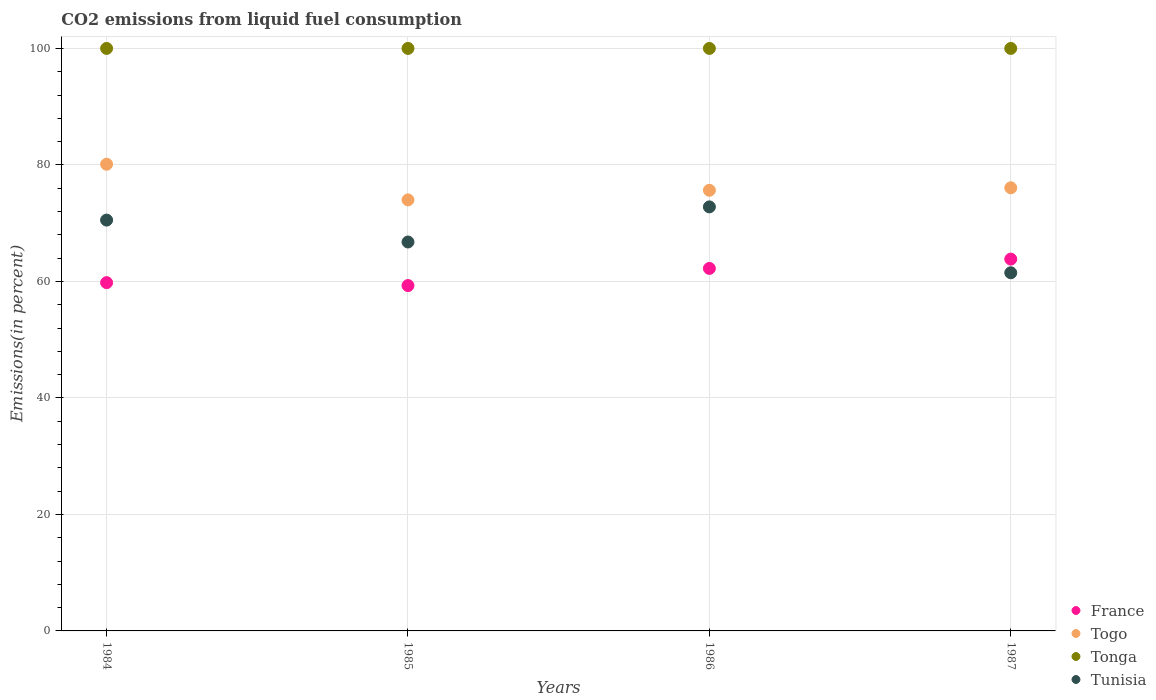Is the number of dotlines equal to the number of legend labels?
Your answer should be very brief. Yes. What is the total CO2 emitted in Togo in 1987?
Offer a very short reply. 76.08. Across all years, what is the maximum total CO2 emitted in Tunisia?
Give a very brief answer. 72.8. Across all years, what is the minimum total CO2 emitted in Tonga?
Offer a terse response. 100. In which year was the total CO2 emitted in Tonga minimum?
Make the answer very short. 1984. What is the total total CO2 emitted in Togo in the graph?
Keep it short and to the point. 305.84. What is the difference between the total CO2 emitted in Tunisia in 1984 and that in 1986?
Your answer should be very brief. -2.27. What is the difference between the total CO2 emitted in Tonga in 1984 and the total CO2 emitted in France in 1986?
Provide a succinct answer. 37.77. In the year 1986, what is the difference between the total CO2 emitted in Tunisia and total CO2 emitted in France?
Your response must be concise. 10.56. What is the difference between the highest and the second highest total CO2 emitted in Tonga?
Ensure brevity in your answer.  0. In how many years, is the total CO2 emitted in Tonga greater than the average total CO2 emitted in Tonga taken over all years?
Your answer should be very brief. 0. Is it the case that in every year, the sum of the total CO2 emitted in Tonga and total CO2 emitted in Tunisia  is greater than the sum of total CO2 emitted in France and total CO2 emitted in Togo?
Offer a terse response. Yes. Is it the case that in every year, the sum of the total CO2 emitted in Togo and total CO2 emitted in Tunisia  is greater than the total CO2 emitted in France?
Offer a terse response. Yes. How many dotlines are there?
Provide a succinct answer. 4. How many years are there in the graph?
Offer a terse response. 4. What is the difference between two consecutive major ticks on the Y-axis?
Provide a short and direct response. 20. Are the values on the major ticks of Y-axis written in scientific E-notation?
Keep it short and to the point. No. Does the graph contain grids?
Ensure brevity in your answer.  Yes. Where does the legend appear in the graph?
Your response must be concise. Bottom right. How many legend labels are there?
Offer a very short reply. 4. What is the title of the graph?
Ensure brevity in your answer.  CO2 emissions from liquid fuel consumption. Does "Seychelles" appear as one of the legend labels in the graph?
Ensure brevity in your answer.  No. What is the label or title of the Y-axis?
Offer a terse response. Emissions(in percent). What is the Emissions(in percent) in France in 1984?
Your response must be concise. 59.79. What is the Emissions(in percent) of Togo in 1984?
Your answer should be very brief. 80.12. What is the Emissions(in percent) of Tunisia in 1984?
Your answer should be compact. 70.53. What is the Emissions(in percent) in France in 1985?
Offer a very short reply. 59.29. What is the Emissions(in percent) in Tonga in 1985?
Give a very brief answer. 100. What is the Emissions(in percent) in Tunisia in 1985?
Make the answer very short. 66.77. What is the Emissions(in percent) in France in 1986?
Make the answer very short. 62.23. What is the Emissions(in percent) of Togo in 1986?
Your answer should be compact. 75.65. What is the Emissions(in percent) in Tonga in 1986?
Give a very brief answer. 100. What is the Emissions(in percent) of Tunisia in 1986?
Make the answer very short. 72.8. What is the Emissions(in percent) of France in 1987?
Offer a very short reply. 63.83. What is the Emissions(in percent) of Togo in 1987?
Offer a very short reply. 76.08. What is the Emissions(in percent) of Tunisia in 1987?
Ensure brevity in your answer.  61.49. Across all years, what is the maximum Emissions(in percent) in France?
Offer a very short reply. 63.83. Across all years, what is the maximum Emissions(in percent) of Togo?
Your answer should be very brief. 80.12. Across all years, what is the maximum Emissions(in percent) in Tonga?
Provide a short and direct response. 100. Across all years, what is the maximum Emissions(in percent) of Tunisia?
Make the answer very short. 72.8. Across all years, what is the minimum Emissions(in percent) of France?
Your answer should be very brief. 59.29. Across all years, what is the minimum Emissions(in percent) in Tonga?
Your response must be concise. 100. Across all years, what is the minimum Emissions(in percent) in Tunisia?
Ensure brevity in your answer.  61.49. What is the total Emissions(in percent) of France in the graph?
Ensure brevity in your answer.  245.15. What is the total Emissions(in percent) of Togo in the graph?
Your answer should be very brief. 305.84. What is the total Emissions(in percent) in Tunisia in the graph?
Keep it short and to the point. 271.58. What is the difference between the Emissions(in percent) in France in 1984 and that in 1985?
Your answer should be compact. 0.5. What is the difference between the Emissions(in percent) of Togo in 1984 and that in 1985?
Offer a terse response. 6.12. What is the difference between the Emissions(in percent) of Tonga in 1984 and that in 1985?
Keep it short and to the point. 0. What is the difference between the Emissions(in percent) in Tunisia in 1984 and that in 1985?
Your response must be concise. 3.76. What is the difference between the Emissions(in percent) of France in 1984 and that in 1986?
Make the answer very short. -2.44. What is the difference between the Emissions(in percent) of Togo in 1984 and that in 1986?
Provide a short and direct response. 4.47. What is the difference between the Emissions(in percent) in Tunisia in 1984 and that in 1986?
Keep it short and to the point. -2.27. What is the difference between the Emissions(in percent) of France in 1984 and that in 1987?
Keep it short and to the point. -4.04. What is the difference between the Emissions(in percent) in Togo in 1984 and that in 1987?
Your answer should be very brief. 4.04. What is the difference between the Emissions(in percent) in Tunisia in 1984 and that in 1987?
Provide a succinct answer. 9.04. What is the difference between the Emissions(in percent) of France in 1985 and that in 1986?
Keep it short and to the point. -2.94. What is the difference between the Emissions(in percent) of Togo in 1985 and that in 1986?
Make the answer very short. -1.65. What is the difference between the Emissions(in percent) in Tonga in 1985 and that in 1986?
Give a very brief answer. 0. What is the difference between the Emissions(in percent) of Tunisia in 1985 and that in 1986?
Give a very brief answer. -6.03. What is the difference between the Emissions(in percent) of France in 1985 and that in 1987?
Give a very brief answer. -4.54. What is the difference between the Emissions(in percent) of Togo in 1985 and that in 1987?
Provide a short and direct response. -2.08. What is the difference between the Emissions(in percent) of Tonga in 1985 and that in 1987?
Your answer should be compact. 0. What is the difference between the Emissions(in percent) of Tunisia in 1985 and that in 1987?
Provide a succinct answer. 5.28. What is the difference between the Emissions(in percent) in France in 1986 and that in 1987?
Keep it short and to the point. -1.6. What is the difference between the Emissions(in percent) of Togo in 1986 and that in 1987?
Make the answer very short. -0.43. What is the difference between the Emissions(in percent) in Tonga in 1986 and that in 1987?
Keep it short and to the point. 0. What is the difference between the Emissions(in percent) in Tunisia in 1986 and that in 1987?
Keep it short and to the point. 11.31. What is the difference between the Emissions(in percent) in France in 1984 and the Emissions(in percent) in Togo in 1985?
Your answer should be very brief. -14.21. What is the difference between the Emissions(in percent) of France in 1984 and the Emissions(in percent) of Tonga in 1985?
Your response must be concise. -40.21. What is the difference between the Emissions(in percent) in France in 1984 and the Emissions(in percent) in Tunisia in 1985?
Your answer should be compact. -6.98. What is the difference between the Emissions(in percent) in Togo in 1984 and the Emissions(in percent) in Tonga in 1985?
Your answer should be very brief. -19.88. What is the difference between the Emissions(in percent) in Togo in 1984 and the Emissions(in percent) in Tunisia in 1985?
Give a very brief answer. 13.35. What is the difference between the Emissions(in percent) in Tonga in 1984 and the Emissions(in percent) in Tunisia in 1985?
Your answer should be very brief. 33.23. What is the difference between the Emissions(in percent) in France in 1984 and the Emissions(in percent) in Togo in 1986?
Give a very brief answer. -15.86. What is the difference between the Emissions(in percent) in France in 1984 and the Emissions(in percent) in Tonga in 1986?
Offer a very short reply. -40.21. What is the difference between the Emissions(in percent) of France in 1984 and the Emissions(in percent) of Tunisia in 1986?
Provide a short and direct response. -13. What is the difference between the Emissions(in percent) of Togo in 1984 and the Emissions(in percent) of Tonga in 1986?
Your response must be concise. -19.88. What is the difference between the Emissions(in percent) in Togo in 1984 and the Emissions(in percent) in Tunisia in 1986?
Provide a short and direct response. 7.32. What is the difference between the Emissions(in percent) in Tonga in 1984 and the Emissions(in percent) in Tunisia in 1986?
Provide a short and direct response. 27.2. What is the difference between the Emissions(in percent) of France in 1984 and the Emissions(in percent) of Togo in 1987?
Offer a terse response. -16.28. What is the difference between the Emissions(in percent) in France in 1984 and the Emissions(in percent) in Tonga in 1987?
Your response must be concise. -40.21. What is the difference between the Emissions(in percent) of France in 1984 and the Emissions(in percent) of Tunisia in 1987?
Give a very brief answer. -1.69. What is the difference between the Emissions(in percent) in Togo in 1984 and the Emissions(in percent) in Tonga in 1987?
Your answer should be very brief. -19.88. What is the difference between the Emissions(in percent) of Togo in 1984 and the Emissions(in percent) of Tunisia in 1987?
Keep it short and to the point. 18.63. What is the difference between the Emissions(in percent) in Tonga in 1984 and the Emissions(in percent) in Tunisia in 1987?
Keep it short and to the point. 38.51. What is the difference between the Emissions(in percent) of France in 1985 and the Emissions(in percent) of Togo in 1986?
Give a very brief answer. -16.36. What is the difference between the Emissions(in percent) in France in 1985 and the Emissions(in percent) in Tonga in 1986?
Make the answer very short. -40.71. What is the difference between the Emissions(in percent) in France in 1985 and the Emissions(in percent) in Tunisia in 1986?
Your response must be concise. -13.51. What is the difference between the Emissions(in percent) in Togo in 1985 and the Emissions(in percent) in Tonga in 1986?
Give a very brief answer. -26. What is the difference between the Emissions(in percent) in Togo in 1985 and the Emissions(in percent) in Tunisia in 1986?
Offer a terse response. 1.2. What is the difference between the Emissions(in percent) of Tonga in 1985 and the Emissions(in percent) of Tunisia in 1986?
Ensure brevity in your answer.  27.2. What is the difference between the Emissions(in percent) of France in 1985 and the Emissions(in percent) of Togo in 1987?
Provide a succinct answer. -16.79. What is the difference between the Emissions(in percent) of France in 1985 and the Emissions(in percent) of Tonga in 1987?
Keep it short and to the point. -40.71. What is the difference between the Emissions(in percent) of France in 1985 and the Emissions(in percent) of Tunisia in 1987?
Your answer should be compact. -2.2. What is the difference between the Emissions(in percent) of Togo in 1985 and the Emissions(in percent) of Tonga in 1987?
Keep it short and to the point. -26. What is the difference between the Emissions(in percent) of Togo in 1985 and the Emissions(in percent) of Tunisia in 1987?
Your answer should be very brief. 12.51. What is the difference between the Emissions(in percent) in Tonga in 1985 and the Emissions(in percent) in Tunisia in 1987?
Make the answer very short. 38.51. What is the difference between the Emissions(in percent) of France in 1986 and the Emissions(in percent) of Togo in 1987?
Provide a short and direct response. -13.84. What is the difference between the Emissions(in percent) of France in 1986 and the Emissions(in percent) of Tonga in 1987?
Give a very brief answer. -37.77. What is the difference between the Emissions(in percent) in France in 1986 and the Emissions(in percent) in Tunisia in 1987?
Ensure brevity in your answer.  0.75. What is the difference between the Emissions(in percent) in Togo in 1986 and the Emissions(in percent) in Tonga in 1987?
Your response must be concise. -24.35. What is the difference between the Emissions(in percent) in Togo in 1986 and the Emissions(in percent) in Tunisia in 1987?
Offer a terse response. 14.16. What is the difference between the Emissions(in percent) of Tonga in 1986 and the Emissions(in percent) of Tunisia in 1987?
Your response must be concise. 38.51. What is the average Emissions(in percent) in France per year?
Your answer should be very brief. 61.29. What is the average Emissions(in percent) in Togo per year?
Offer a terse response. 76.46. What is the average Emissions(in percent) in Tonga per year?
Keep it short and to the point. 100. What is the average Emissions(in percent) in Tunisia per year?
Your answer should be compact. 67.9. In the year 1984, what is the difference between the Emissions(in percent) in France and Emissions(in percent) in Togo?
Your response must be concise. -20.33. In the year 1984, what is the difference between the Emissions(in percent) of France and Emissions(in percent) of Tonga?
Give a very brief answer. -40.21. In the year 1984, what is the difference between the Emissions(in percent) in France and Emissions(in percent) in Tunisia?
Provide a short and direct response. -10.74. In the year 1984, what is the difference between the Emissions(in percent) of Togo and Emissions(in percent) of Tonga?
Ensure brevity in your answer.  -19.88. In the year 1984, what is the difference between the Emissions(in percent) of Togo and Emissions(in percent) of Tunisia?
Make the answer very short. 9.59. In the year 1984, what is the difference between the Emissions(in percent) in Tonga and Emissions(in percent) in Tunisia?
Make the answer very short. 29.47. In the year 1985, what is the difference between the Emissions(in percent) in France and Emissions(in percent) in Togo?
Keep it short and to the point. -14.71. In the year 1985, what is the difference between the Emissions(in percent) of France and Emissions(in percent) of Tonga?
Your answer should be compact. -40.71. In the year 1985, what is the difference between the Emissions(in percent) of France and Emissions(in percent) of Tunisia?
Give a very brief answer. -7.48. In the year 1985, what is the difference between the Emissions(in percent) in Togo and Emissions(in percent) in Tunisia?
Offer a very short reply. 7.23. In the year 1985, what is the difference between the Emissions(in percent) of Tonga and Emissions(in percent) of Tunisia?
Offer a terse response. 33.23. In the year 1986, what is the difference between the Emissions(in percent) of France and Emissions(in percent) of Togo?
Provide a short and direct response. -13.41. In the year 1986, what is the difference between the Emissions(in percent) in France and Emissions(in percent) in Tonga?
Provide a succinct answer. -37.77. In the year 1986, what is the difference between the Emissions(in percent) in France and Emissions(in percent) in Tunisia?
Your answer should be very brief. -10.56. In the year 1986, what is the difference between the Emissions(in percent) of Togo and Emissions(in percent) of Tonga?
Offer a terse response. -24.35. In the year 1986, what is the difference between the Emissions(in percent) in Togo and Emissions(in percent) in Tunisia?
Make the answer very short. 2.85. In the year 1986, what is the difference between the Emissions(in percent) in Tonga and Emissions(in percent) in Tunisia?
Give a very brief answer. 27.2. In the year 1987, what is the difference between the Emissions(in percent) of France and Emissions(in percent) of Togo?
Your answer should be very brief. -12.24. In the year 1987, what is the difference between the Emissions(in percent) in France and Emissions(in percent) in Tonga?
Keep it short and to the point. -36.17. In the year 1987, what is the difference between the Emissions(in percent) in France and Emissions(in percent) in Tunisia?
Offer a terse response. 2.35. In the year 1987, what is the difference between the Emissions(in percent) in Togo and Emissions(in percent) in Tonga?
Make the answer very short. -23.92. In the year 1987, what is the difference between the Emissions(in percent) in Togo and Emissions(in percent) in Tunisia?
Offer a very short reply. 14.59. In the year 1987, what is the difference between the Emissions(in percent) of Tonga and Emissions(in percent) of Tunisia?
Offer a terse response. 38.51. What is the ratio of the Emissions(in percent) of France in 1984 to that in 1985?
Provide a short and direct response. 1.01. What is the ratio of the Emissions(in percent) of Togo in 1984 to that in 1985?
Offer a terse response. 1.08. What is the ratio of the Emissions(in percent) of Tunisia in 1984 to that in 1985?
Your answer should be compact. 1.06. What is the ratio of the Emissions(in percent) in France in 1984 to that in 1986?
Your answer should be very brief. 0.96. What is the ratio of the Emissions(in percent) of Togo in 1984 to that in 1986?
Your answer should be very brief. 1.06. What is the ratio of the Emissions(in percent) in Tunisia in 1984 to that in 1986?
Offer a very short reply. 0.97. What is the ratio of the Emissions(in percent) of France in 1984 to that in 1987?
Your response must be concise. 0.94. What is the ratio of the Emissions(in percent) of Togo in 1984 to that in 1987?
Make the answer very short. 1.05. What is the ratio of the Emissions(in percent) in Tonga in 1984 to that in 1987?
Keep it short and to the point. 1. What is the ratio of the Emissions(in percent) in Tunisia in 1984 to that in 1987?
Provide a succinct answer. 1.15. What is the ratio of the Emissions(in percent) in France in 1985 to that in 1986?
Offer a terse response. 0.95. What is the ratio of the Emissions(in percent) of Togo in 1985 to that in 1986?
Your answer should be very brief. 0.98. What is the ratio of the Emissions(in percent) in Tonga in 1985 to that in 1986?
Ensure brevity in your answer.  1. What is the ratio of the Emissions(in percent) of Tunisia in 1985 to that in 1986?
Ensure brevity in your answer.  0.92. What is the ratio of the Emissions(in percent) of France in 1985 to that in 1987?
Offer a very short reply. 0.93. What is the ratio of the Emissions(in percent) in Togo in 1985 to that in 1987?
Offer a terse response. 0.97. What is the ratio of the Emissions(in percent) of Tunisia in 1985 to that in 1987?
Your answer should be compact. 1.09. What is the ratio of the Emissions(in percent) of France in 1986 to that in 1987?
Make the answer very short. 0.97. What is the ratio of the Emissions(in percent) in Togo in 1986 to that in 1987?
Your answer should be very brief. 0.99. What is the ratio of the Emissions(in percent) of Tonga in 1986 to that in 1987?
Offer a terse response. 1. What is the ratio of the Emissions(in percent) in Tunisia in 1986 to that in 1987?
Keep it short and to the point. 1.18. What is the difference between the highest and the second highest Emissions(in percent) in France?
Your answer should be very brief. 1.6. What is the difference between the highest and the second highest Emissions(in percent) of Togo?
Keep it short and to the point. 4.04. What is the difference between the highest and the second highest Emissions(in percent) in Tunisia?
Give a very brief answer. 2.27. What is the difference between the highest and the lowest Emissions(in percent) in France?
Your answer should be very brief. 4.54. What is the difference between the highest and the lowest Emissions(in percent) of Togo?
Ensure brevity in your answer.  6.12. What is the difference between the highest and the lowest Emissions(in percent) in Tonga?
Offer a very short reply. 0. What is the difference between the highest and the lowest Emissions(in percent) of Tunisia?
Your response must be concise. 11.31. 